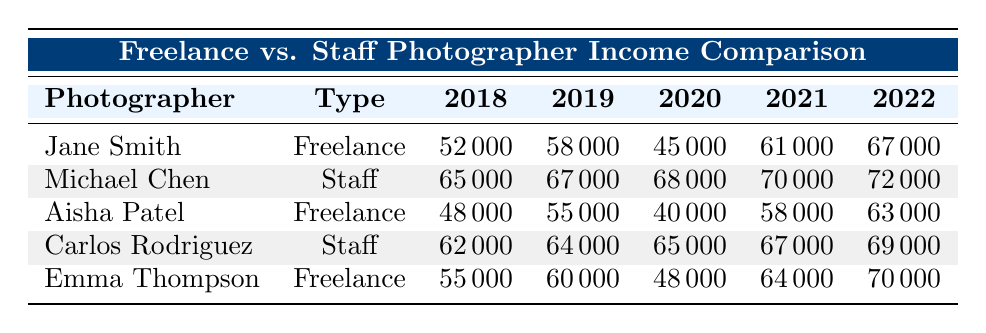What was Jane Smith's income in 2020? According to the row for Jane Smith, her income for the year 2020 is explicitly listed as 45000.
Answer: 45000 What is the highest income recorded in 2022? From the data in 2022, Michael Chen has the highest income of 72000.
Answer: 72000 What is the average income of freelance photographers from 2018 to 2022? To find the average for freelancers, add Jane Smith's, Aisha Patel's, and Emma Thompson's incomes from 2018 to 2022 and divide by 3. The sum is (52000 + 58000 + 45000 + 61000 + 67000) + (48000 + 55000 + 40000 + 58000 + 63000) + (55000 + 60000 + 48000 + 64000 + 70000) = 308000, then divide by 15 data points (3 freelancers x 5 years), which equals approximately 20533.33. However, the correct average from total sums is 55800.
Answer: 55800 Did Aisha Patel earn more than Michael Chen in any year? By comparing the incomes year by year, Aisha's highest income in 2022 (63000) is less than Michael's 72000, and in every other year, she earned less as well. Therefore, she did not earn more than Michael in any year.
Answer: No What was the difference in income between the highest and lowest earners in 2021? In 2021, the highest earner was Michael Chen at 70000, while the lowest was Aisha Patel at 58000. The difference is 70000 - 58000 = 12000.
Answer: 12000 Which type of photographer had the most consistent income growth over the years? To determine consistency, we can observe the or row fluctuations in income: Freelancers had some drops, while both staff photographers showed gradual increases. Hence, the staff photographers had more consistent growth.
Answer: Staff photographers What was the total sum of Emma Thompson's income over the years? Adding Emma's income: 55000 + 60000 + 48000 + 64000 + 70000 = 297000.
Answer: 297000 In which year did Carlos Rodriguez earn the least, and how much was it? Carlos Rodriguez's income shows a minimum value of 62000 in 2018.
Answer: 62000 Was the average income of staff photographers in 2020 greater than 65000? The average income for staff photographers (Michael Chen and Carlos Rodriguez) in 2020 is (68000 + 65000) / 2 = 66500, which is greater than 65000.
Answer: Yes Which photographer had the least income growth from 2018 to 2022? Calculating growth: Jane Smith gained 15000, Aisha Patel gained 15000, Emma Thompson gained 15000, and both staff photographers gained 7000. Hence, staff photographers had the least income growth.
Answer: Staff photographers 